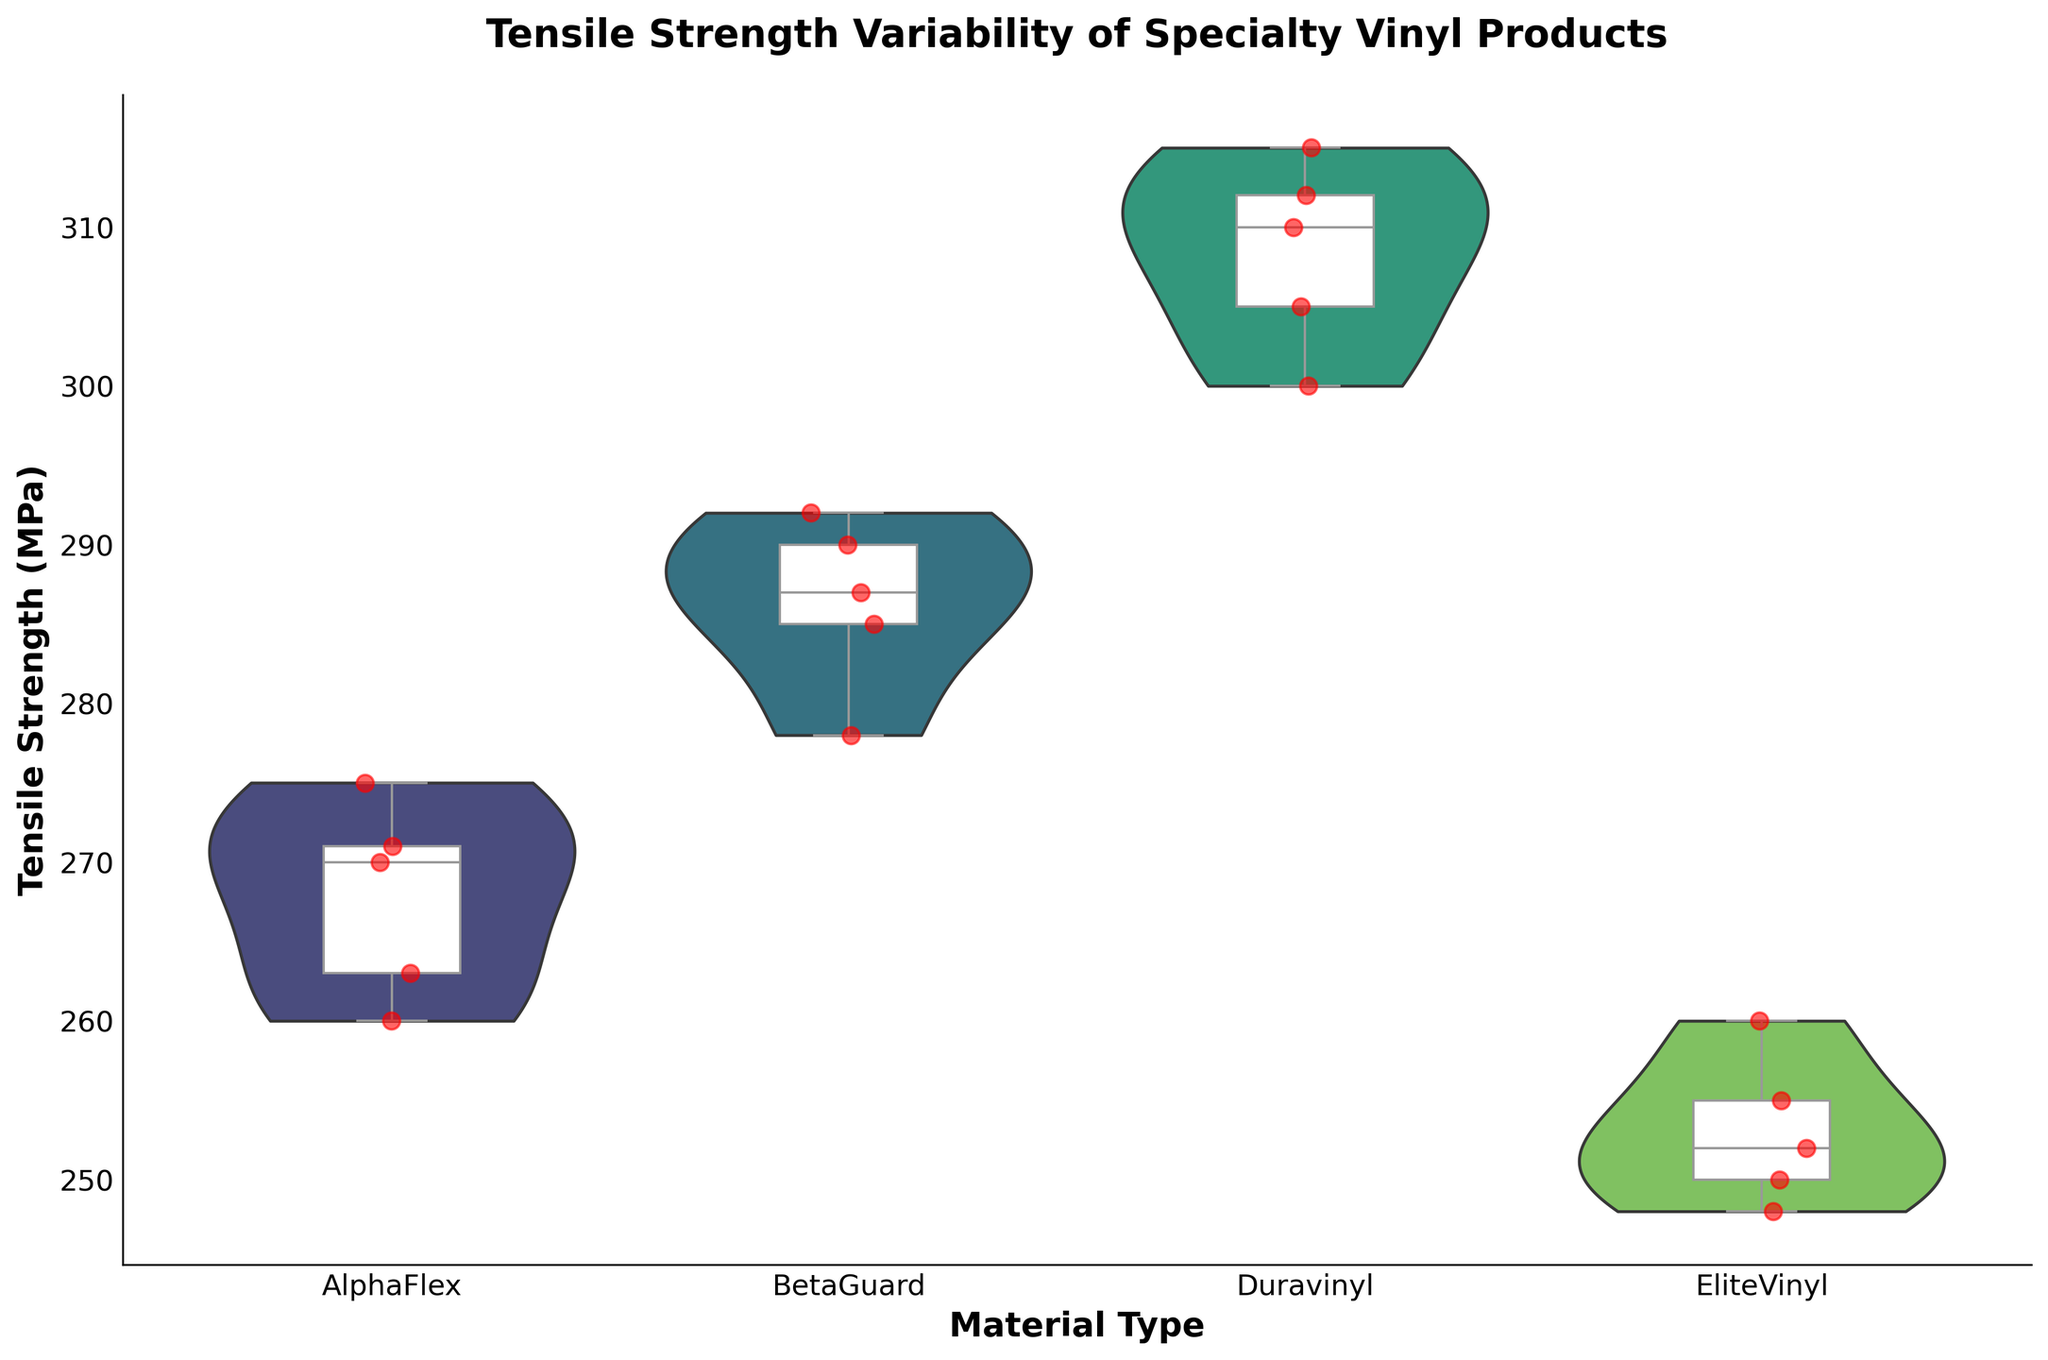What's the title of the chart? The title of the chart is prominently displayed at the top. It reads, "Tensile Strength Variability of Specialty Vinyl Products".
Answer: Tensile Strength Variability of Specialty Vinyl Products How many different materials are compared in the chart? The x-axis lists the different material types, which helps in counting the distinct materials. There are four distinct materials shown.
Answer: Four Which material has the highest median tensile strength? The box plots within the violin plots indicate the medians. By visually inspecting, the median line is highest for Duravinyl.
Answer: Duravinyl What is the range of tensile strengths for EliteVinyl? The range can be determined from the box plot within the violin plot for EliteVinyl. The bottom quartile is at around 248 MPa and the top quartile is around 260 MPa. So, the range is from 248 MPa to 260 MPa.
Answer: 248 MPa to 260 MPa Which material shows the second widest distribution of tensile strengths? The width of the violin plots represents the distribution of the data. After Duravinyl, which shows the widest distribution, BetaGuard appears to have the second widest distribution.
Answer: BetaGuard What is the median tensile strength of AlphaFlex? The box plot within the violin plot for AlphaFlex shows the median, which is the line in the middle of the box. It is around 270 MPa.
Answer: 270 MPa Which material exhibits the least variability in tensile strength? Variability is indicated by the width and spread of the violin plot as well as the length of the interquartile range in the box plot. EliteVinyl appears to have the least variability.
Answer: EliteVinyl How does the median strength of BetaGuard compare to AlphaFlex? By comparing the median lines in the box plots, BetaGuard has a higher median tensile strength than AlphaFlex.
Answer: BetaGuard has a higher median What material shows the highest single tensile strength measurement? Looking at the highest points in each violin plot, Duravinyl has the highest single tensile strength measurement, reaching up to 315 MPa.
Answer: Duravinyl Which material's tensile strengths are the most tightly clustered? The clustering can be observed through the box plots' interquartile range and the violin plots' density around the median. EliteVinyl’s tensile strengths are most tightly clustered.
Answer: EliteVinyl 